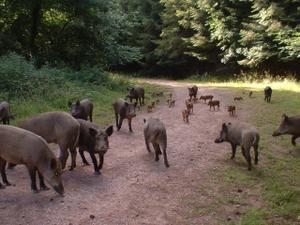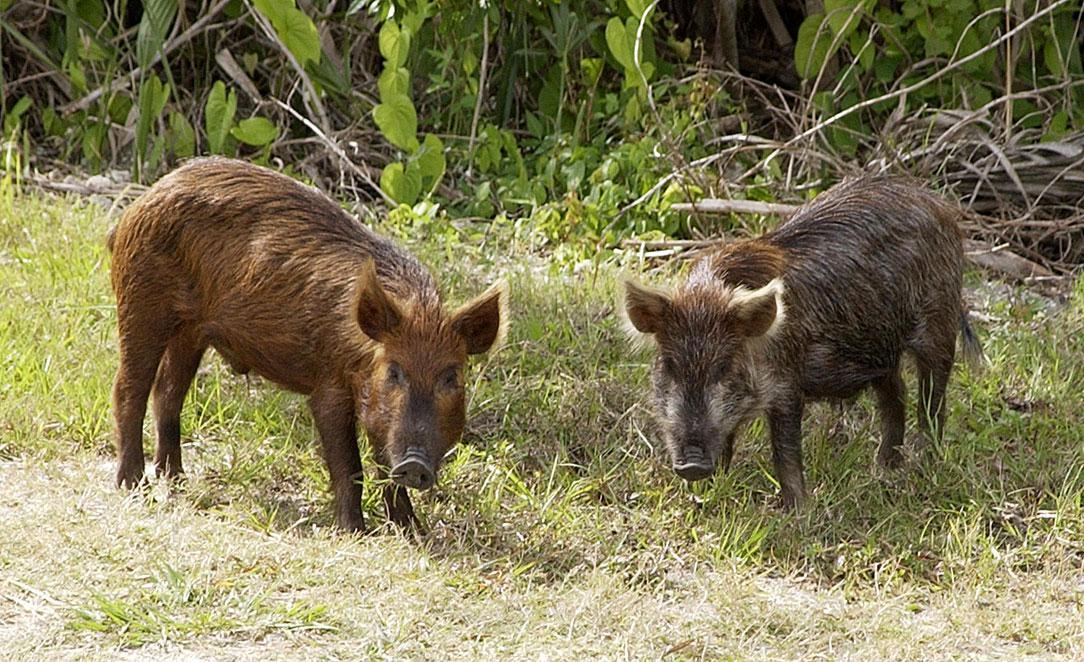The first image is the image on the left, the second image is the image on the right. Evaluate the accuracy of this statement regarding the images: "The right image contains exactly two boars.". Is it true? Answer yes or no. Yes. 